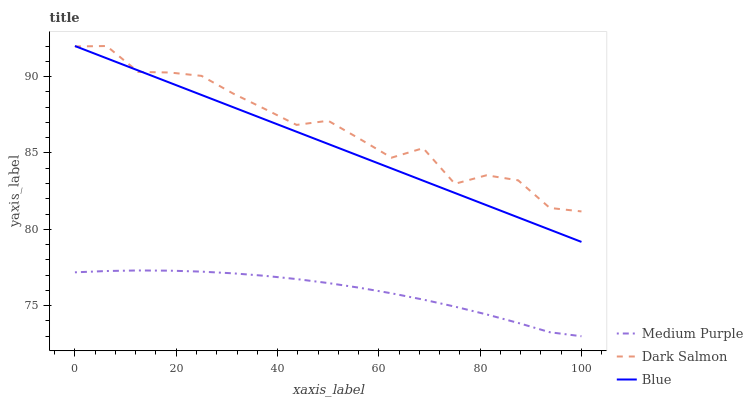Does Medium Purple have the minimum area under the curve?
Answer yes or no. Yes. Does Dark Salmon have the maximum area under the curve?
Answer yes or no. Yes. Does Blue have the minimum area under the curve?
Answer yes or no. No. Does Blue have the maximum area under the curve?
Answer yes or no. No. Is Blue the smoothest?
Answer yes or no. Yes. Is Dark Salmon the roughest?
Answer yes or no. Yes. Is Dark Salmon the smoothest?
Answer yes or no. No. Is Blue the roughest?
Answer yes or no. No. Does Medium Purple have the lowest value?
Answer yes or no. Yes. Does Blue have the lowest value?
Answer yes or no. No. Does Dark Salmon have the highest value?
Answer yes or no. Yes. Is Medium Purple less than Dark Salmon?
Answer yes or no. Yes. Is Dark Salmon greater than Medium Purple?
Answer yes or no. Yes. Does Blue intersect Dark Salmon?
Answer yes or no. Yes. Is Blue less than Dark Salmon?
Answer yes or no. No. Is Blue greater than Dark Salmon?
Answer yes or no. No. Does Medium Purple intersect Dark Salmon?
Answer yes or no. No. 